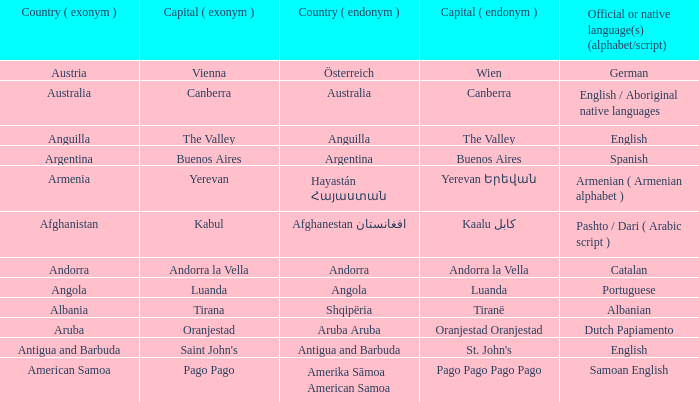Would you mind parsing the complete table? {'header': ['Country ( exonym )', 'Capital ( exonym )', 'Country ( endonym )', 'Capital ( endonym )', 'Official or native language(s) (alphabet/script)'], 'rows': [['Austria', 'Vienna', 'Österreich', 'Wien', 'German'], ['Australia', 'Canberra', 'Australia', 'Canberra', 'English / Aboriginal native languages'], ['Anguilla', 'The Valley', 'Anguilla', 'The Valley', 'English'], ['Argentina', 'Buenos Aires', 'Argentina', 'Buenos Aires', 'Spanish'], ['Armenia', 'Yerevan', 'Hayastán Հայաստան', 'Yerevan Երեվան', 'Armenian ( Armenian alphabet )'], ['Afghanistan', 'Kabul', 'Afghanestan افغانستان', 'Kaalu كابل', 'Pashto / Dari ( Arabic script )'], ['Andorra', 'Andorra la Vella', 'Andorra', 'Andorra la Vella', 'Catalan'], ['Angola', 'Luanda', 'Angola', 'Luanda', 'Portuguese'], ['Albania', 'Tirana', 'Shqipëria', 'Tiranë', 'Albanian'], ['Aruba', 'Oranjestad', 'Aruba Aruba', 'Oranjestad Oranjestad', 'Dutch Papiamento'], ['Antigua and Barbuda', "Saint John's", 'Antigua and Barbuda', "St. John's", 'English'], ['American Samoa', 'Pago Pago', 'Amerika Sāmoa American Samoa', 'Pago Pago Pago Pago', 'Samoan English']]} What is the local name given to the city of Canberra? Canberra. 